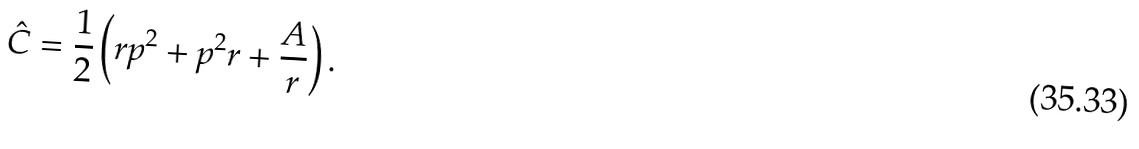<formula> <loc_0><loc_0><loc_500><loc_500>\hat { C } = \frac { 1 } { 2 } \left ( r p ^ { 2 } + p ^ { 2 } r + \frac { A } { r } \right ) .</formula> 